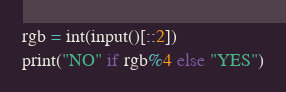Convert code to text. <code><loc_0><loc_0><loc_500><loc_500><_Python_>rgb = int(input()[::2])
print("NO" if rgb%4 else "YES")</code> 